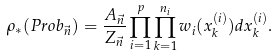<formula> <loc_0><loc_0><loc_500><loc_500>\rho _ { * } ( P r o b _ { \vec { n } } ) = \frac { A _ { \vec { n } } } { Z _ { \vec { n } } } \prod _ { i = 1 } ^ { p } \prod _ { k = 1 } ^ { n _ { i } } w _ { i } ( x _ { k } ^ { ( i ) } ) d x _ { k } ^ { ( i ) } .</formula> 